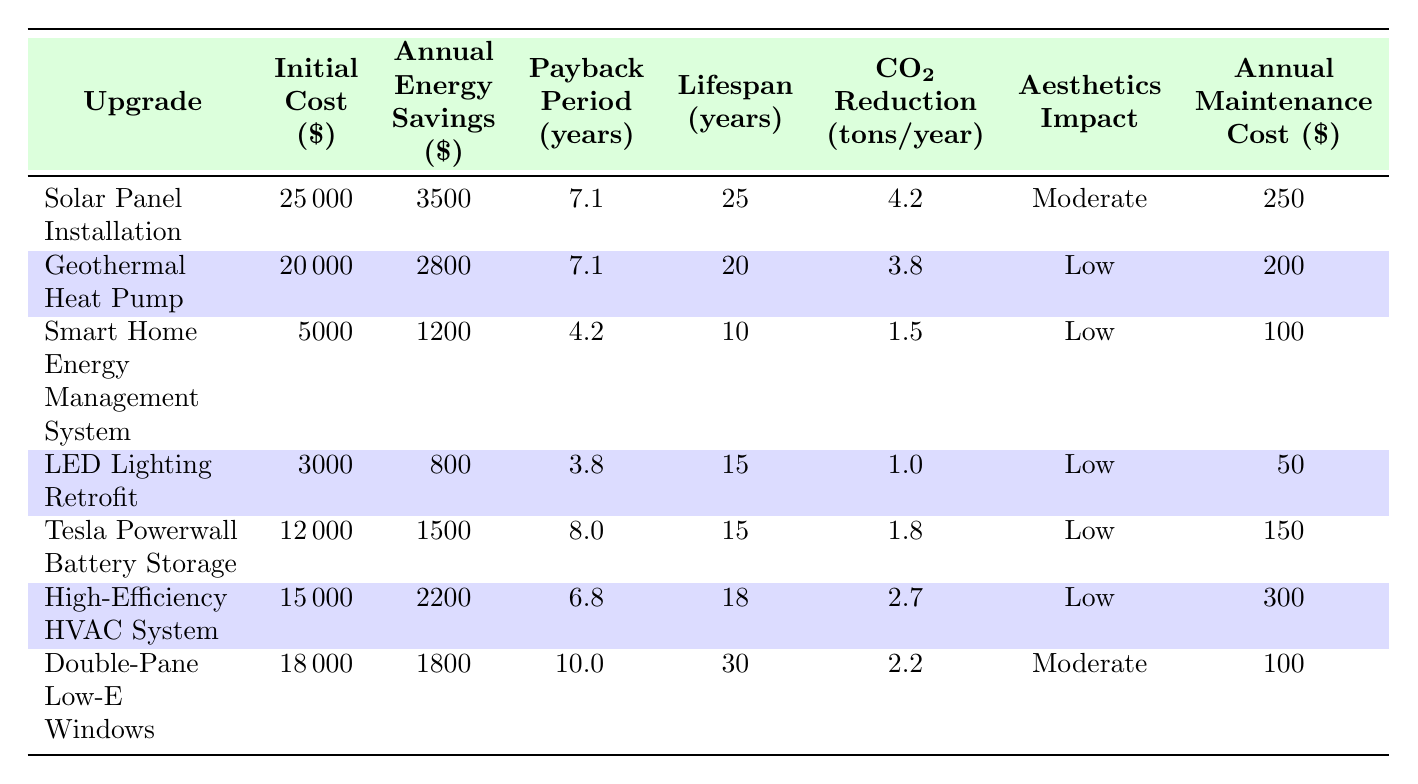What is the initial cost of installing solar panels? The table lists 'Solar Panel Installation' with an initial cost of $25000.
Answer: 25000 Which upgrade has the lowest annual maintenance cost? In the table, the 'LED Lighting Retrofit' has an annual maintenance cost of $50, which is lower than the others.
Answer: 50 What is the total CO2 reduction per year for both solar panels and geothermal heat pumps? The CO2 reduction for 'Solar Panel Installation' is 4.2 tons/year, and for 'Geothermal Heat Pump' it is 3.8 tons/year. Adding these gives 4.2 + 3.8 = 8.0 tons/year.
Answer: 8.0 Is the payback period for high-efficiency HVAC system shorter than that for double-pane low-E windows? The payback period for 'High-Efficiency HVAC System' is 6.8 years, while for 'Double-Pane Low-E Windows' it is 10.0 years. Since 6.8 is less than 10.0, the statement is true.
Answer: Yes What is the average annual energy savings from all the upgrades? The savings are: 3500 + 2800 + 1200 + 800 + 1500 + 2200 + 1800 = 13600. There are 7 upgrades, so the average is 13600 / 7 ≈ 1942.86.
Answer: 1942.86 Which upgrade has the longest lifespan? The table indicates that 'Double-Pane Low-E Windows' have the longest lifespan at 30 years, compared to others.
Answer: 30 What is the difference in annual energy savings between the Tesla Powerwall and LED Lighting Retrofit? The annual energy savings for 'Tesla Powerwall Battery Storage' is 1500, and for 'LED Lighting Retrofit' it is 800. The difference is 1500 - 800 = 700.
Answer: 700 Is the aesthetics impact of geothermal heat pump high? The aesthetics impact for 'Geothermal Heat Pump' is listed as 'Low', not high. Therefore, the statement is false.
Answer: No What is the total initial cost of implementing the three least expensive upgrades? The three least expensive upgrades are 'LED Lighting Retrofit' at $3000, 'Smart Home Energy Management System' at $5000, and 'Tesla Powerwall Battery Storage' at $12000. Summing these gives 3000 + 5000 + 12000 = 20000.
Answer: 20000 